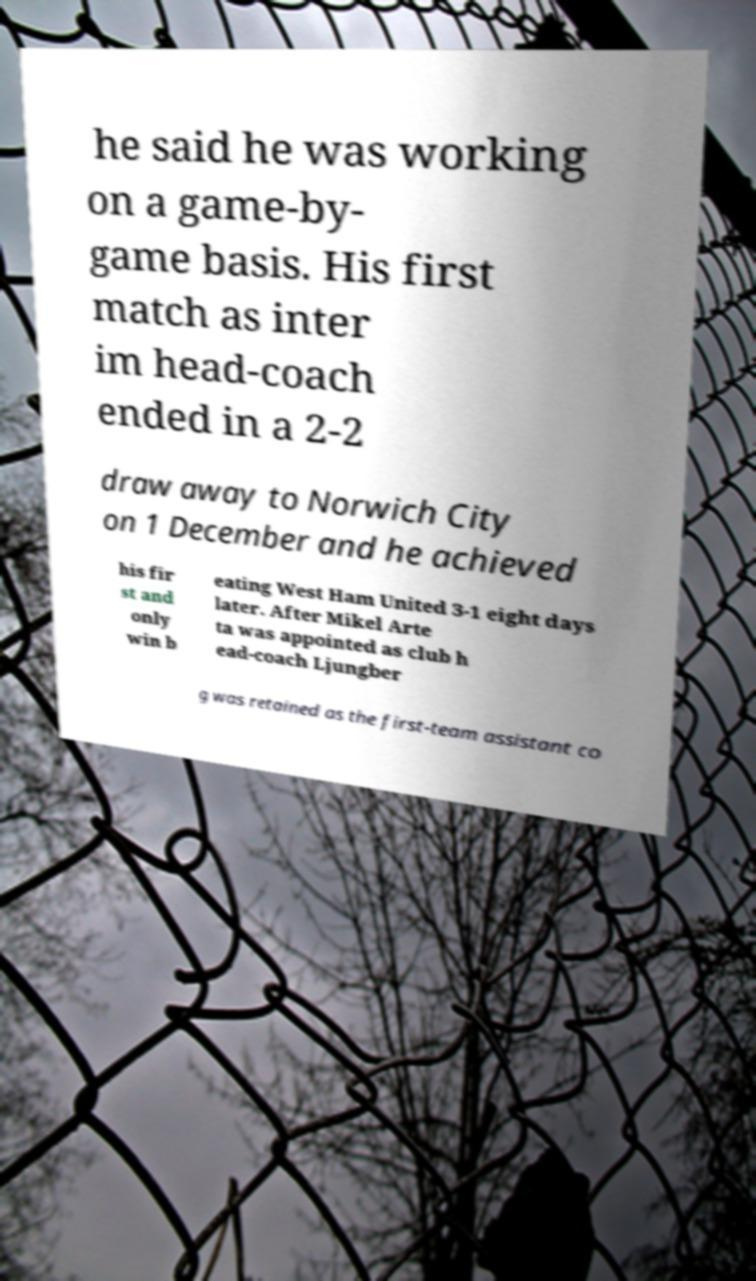Please identify and transcribe the text found in this image. he said he was working on a game-by- game basis. His first match as inter im head-coach ended in a 2-2 draw away to Norwich City on 1 December and he achieved his fir st and only win b eating West Ham United 3-1 eight days later. After Mikel Arte ta was appointed as club h ead-coach Ljungber g was retained as the first-team assistant co 